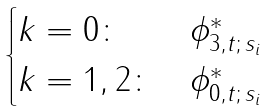Convert formula to latex. <formula><loc_0><loc_0><loc_500><loc_500>\begin{cases} k = 0 \colon & \phi ^ { * } _ { 3 , t ; \, s _ { i } } \\ k = 1 , 2 \colon & \phi ^ { * } _ { 0 , t ; \, s _ { i } } \end{cases}</formula> 